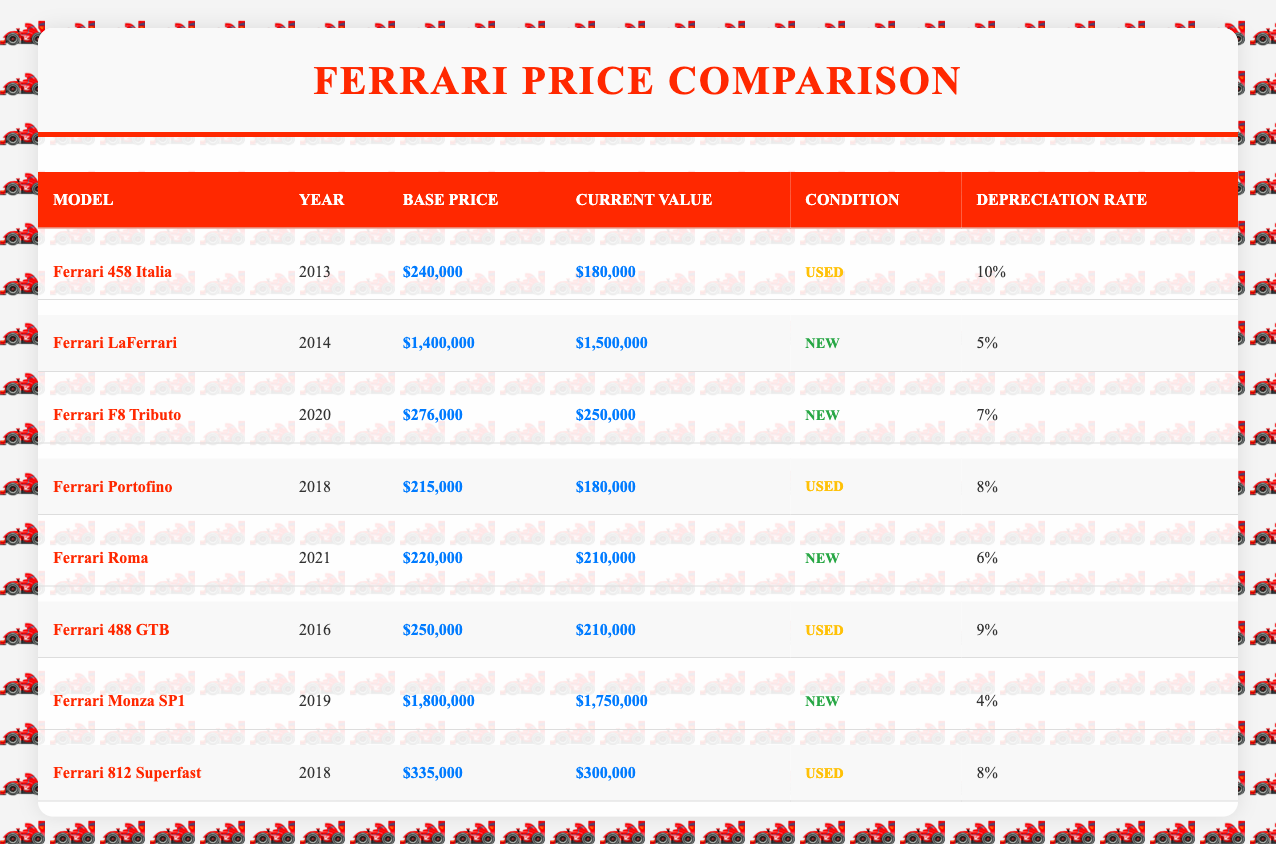What is the base price of the Ferrari LaFerrari? The table shows that the base price for the Ferrari LaFerrari is listed under the "Base Price" column for the year 2014 as $1,400,000.
Answer: $1,400,000 Which Ferrari model has the highest current market value? By looking at the "Current Market Value" column, we see that the Ferrari LaFerrari, with a value of $1,500,000, has the highest market value among all models listed.
Answer: Ferrari LaFerrari What is the annual depreciation rate of the Ferrari 458 Italia? The table indicates that the annual depreciation rate for the Ferrari 458 Italia is shown in the "Depreciation Rate" column as 10%.
Answer: 10% Are there more new or used Ferrari models listed in the table? The table shows 4 new models: LaFerrari, F8 Tributo, Roma, and Monza SP1, and 4 used models: 458 Italia, Portofino, 488 GTB, and 812 Superfast. Therefore, there is no difference in quantity; both have 4 models.
Answer: No What is the average base price of the used Ferrari models? The base prices for the used models are: 458 Italia ($240,000), Portofino ($215,000), 488 GTB ($250,000), and 812 Superfast ($335,000). Summing these values gives $1,040,000, and dividing by the 4 models yields an average base price of $260,000.
Answer: $260,000 What is the difference between the base price and current value of the Ferrari Roma? The base price of Ferrari Roma is $220,000 and the current value is $210,000. The difference is $220,000 - $210,000 = $10,000.
Answer: $10,000 Is it true that the Ferrari Monza SP1 has a lower annual depreciation rate than the Ferrari LaFerrari? The annual depreciation rate for the Monza SP1 is 4% while for LaFerrari it is 5%. Since 4% is indeed lower than 5%, the statement is true.
Answer: Yes Which Ferrari model has the lowest sales volume and what is that volume? By examining the "Sales Volume" column, Ferrari LaFerrari and Ferrari Monza SP1 both have the lowest sales volume at 499 units. Thus, they are tied for the lowest.
Answer: 499 units What is the total current market value of all the new Ferrari models? The current market values for new models are: LaFerrari ($1,500,000), F8 Tributo ($250,000), Roma ($210,000), and Monza SP1 ($1,750,000). Adding these values results in $1,500,000 + $250,000 + $210,000 + $1,750,000 = $3,710,000.
Answer: $3,710,000 Which used Ferrari model has the highest current market value and what is that value? Looking at the "Current Market Value" for used models, the highest is for 812 Superfast at $300,000.
Answer: $300,000 